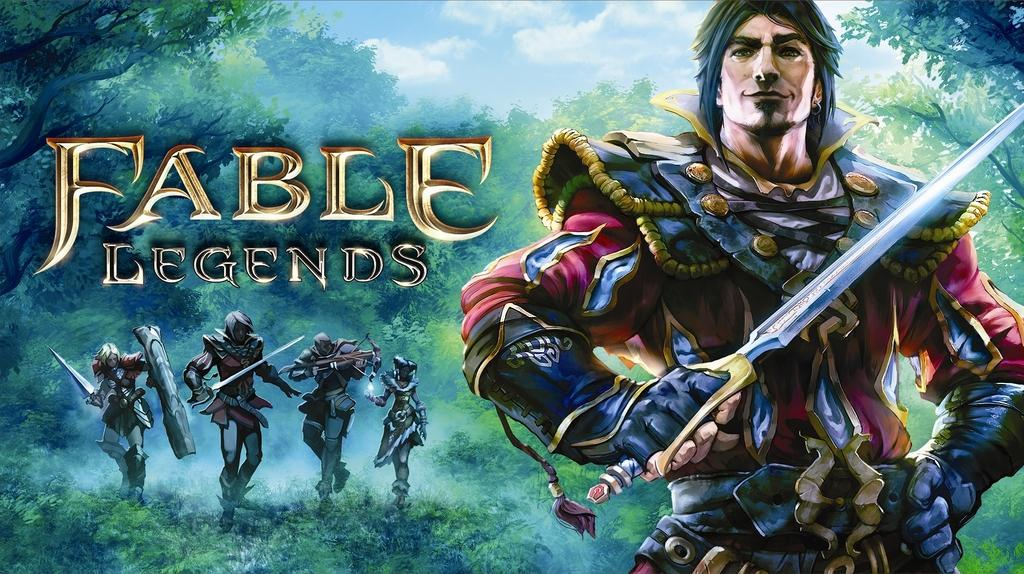Provide a one-sentence caption for the provided image. An artistic drawing of the video game Fable Legends. 